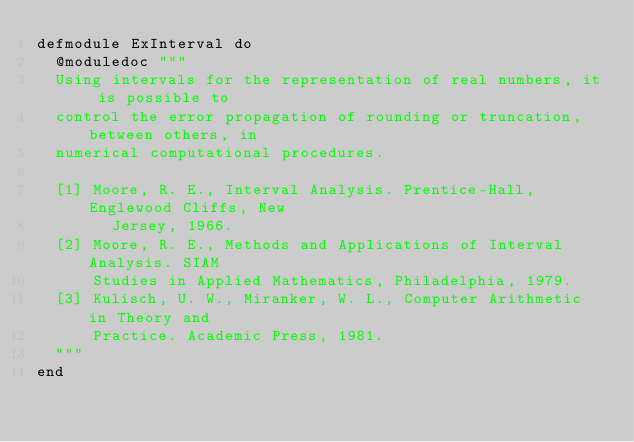<code> <loc_0><loc_0><loc_500><loc_500><_Elixir_>defmodule ExInterval do
  @moduledoc """
  Using intervals for the representation of real numbers, it is possible to
  control the error propagation of rounding or truncation, between others, in
  numerical computational procedures.

  [1] Moore, R. E., Interval Analysis. Prentice-Hall, Englewood Cliffs, New
        Jersey, 1966.
  [2] Moore, R. E., Methods and Applications of Interval Analysis. SIAM
      Studies in Applied Mathematics, Philadelphia, 1979.
  [3] Kulisch, U. W., Miranker, W. L., Computer Arithmetic in Theory and
      Practice. Academic Press, 1981.
  """
end
</code> 